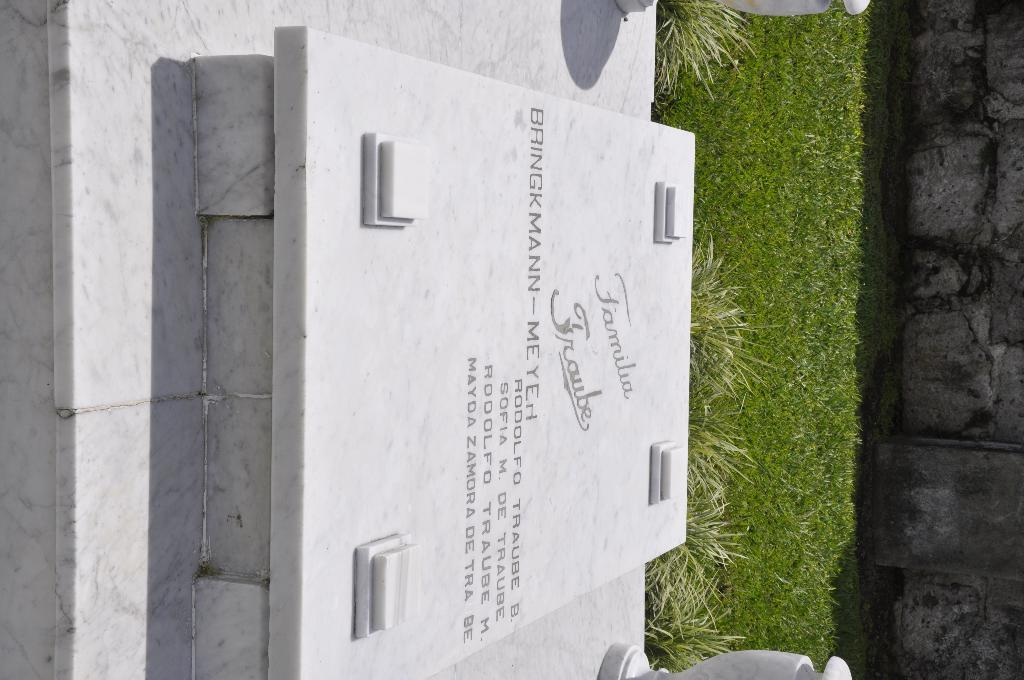What is the main object with text on it in the image? There is a stone with text written on it in the picture. Where is the stone located in the image? The stone is on the left side of the image. What type of vegetation can be seen in the image? There are shrubs and grass in the image. What is the structure on the right side of the image? There is a wall on the right side of the image. Can you tell me how many geese are standing near the stone in the image? There are no geese present in the image; it features a stone with text and a wall on the right side. What advice does the father give to the porter in the image? There is no father or porter present in the image, as it only contains a stone with text, shrubs, grass, and a wall. 